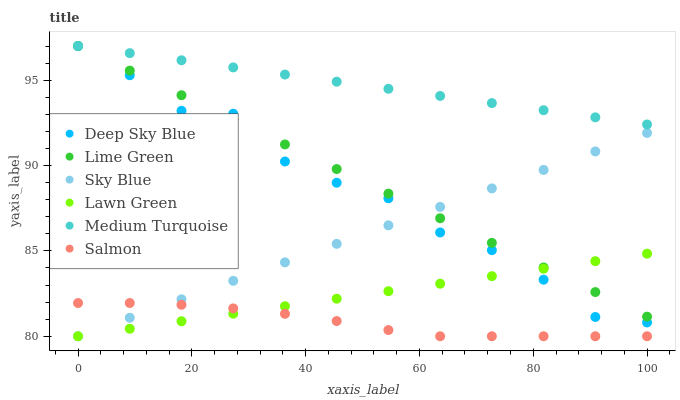Does Salmon have the minimum area under the curve?
Answer yes or no. Yes. Does Medium Turquoise have the maximum area under the curve?
Answer yes or no. Yes. Does Deep Sky Blue have the minimum area under the curve?
Answer yes or no. No. Does Deep Sky Blue have the maximum area under the curve?
Answer yes or no. No. Is Lawn Green the smoothest?
Answer yes or no. Yes. Is Deep Sky Blue the roughest?
Answer yes or no. Yes. Is Salmon the smoothest?
Answer yes or no. No. Is Salmon the roughest?
Answer yes or no. No. Does Lawn Green have the lowest value?
Answer yes or no. Yes. Does Deep Sky Blue have the lowest value?
Answer yes or no. No. Does Lime Green have the highest value?
Answer yes or no. Yes. Does Salmon have the highest value?
Answer yes or no. No. Is Salmon less than Deep Sky Blue?
Answer yes or no. Yes. Is Medium Turquoise greater than Sky Blue?
Answer yes or no. Yes. Does Lawn Green intersect Salmon?
Answer yes or no. Yes. Is Lawn Green less than Salmon?
Answer yes or no. No. Is Lawn Green greater than Salmon?
Answer yes or no. No. Does Salmon intersect Deep Sky Blue?
Answer yes or no. No. 